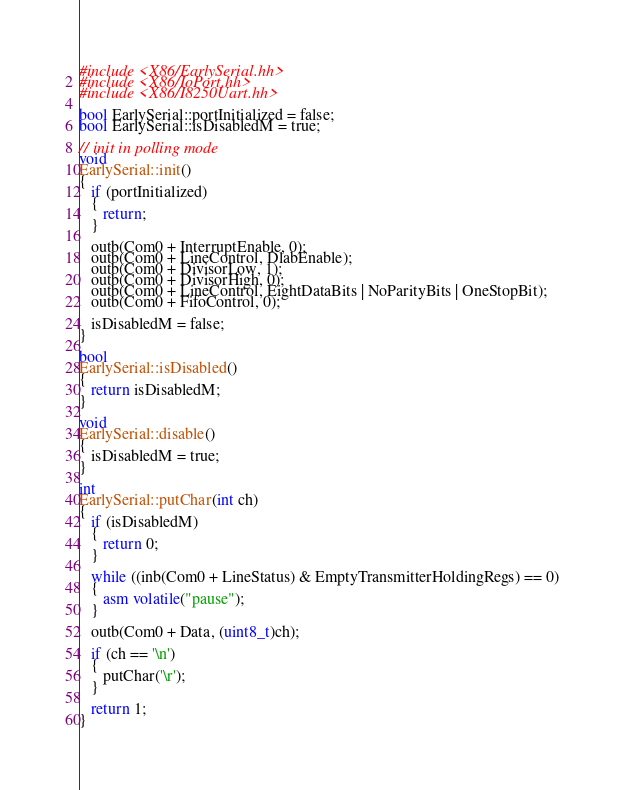<code> <loc_0><loc_0><loc_500><loc_500><_C++_>#include <X86/EarlySerial.hh>
#include <X86/IoPort.hh>
#include <X86/I8250Uart.hh>

bool EarlySerial::portInitialized = false;
bool EarlySerial::isDisabledM = true;

// init in polling mode
void
EarlySerial::init()
{
   if (portInitialized)
   {
      return;
   }
   
   outb(Com0 + InterruptEnable, 0);
   outb(Com0 + LineControl, DlabEnable);
   outb(Com0 + DivisorLow, 1);
   outb(Com0 + DivisorHigh, 0);
   outb(Com0 + LineControl, EightDataBits | NoParityBits | OneStopBit);
   outb(Com0 + FifoControl, 0);

   isDisabledM = false;
}

bool
EarlySerial::isDisabled()
{
   return isDisabledM;
}

void
EarlySerial::disable()
{
   isDisabledM = true;
}

int
EarlySerial::putChar(int ch)
{
   if (isDisabledM)
   {
      return 0;
   }

   while ((inb(Com0 + LineStatus) & EmptyTransmitterHoldingRegs) == 0)
   {
      asm volatile("pause");
   }

   outb(Com0 + Data, (uint8_t)ch);
   
   if (ch == '\n')
   {
      putChar('\r');
   }

   return 1;
}
</code> 